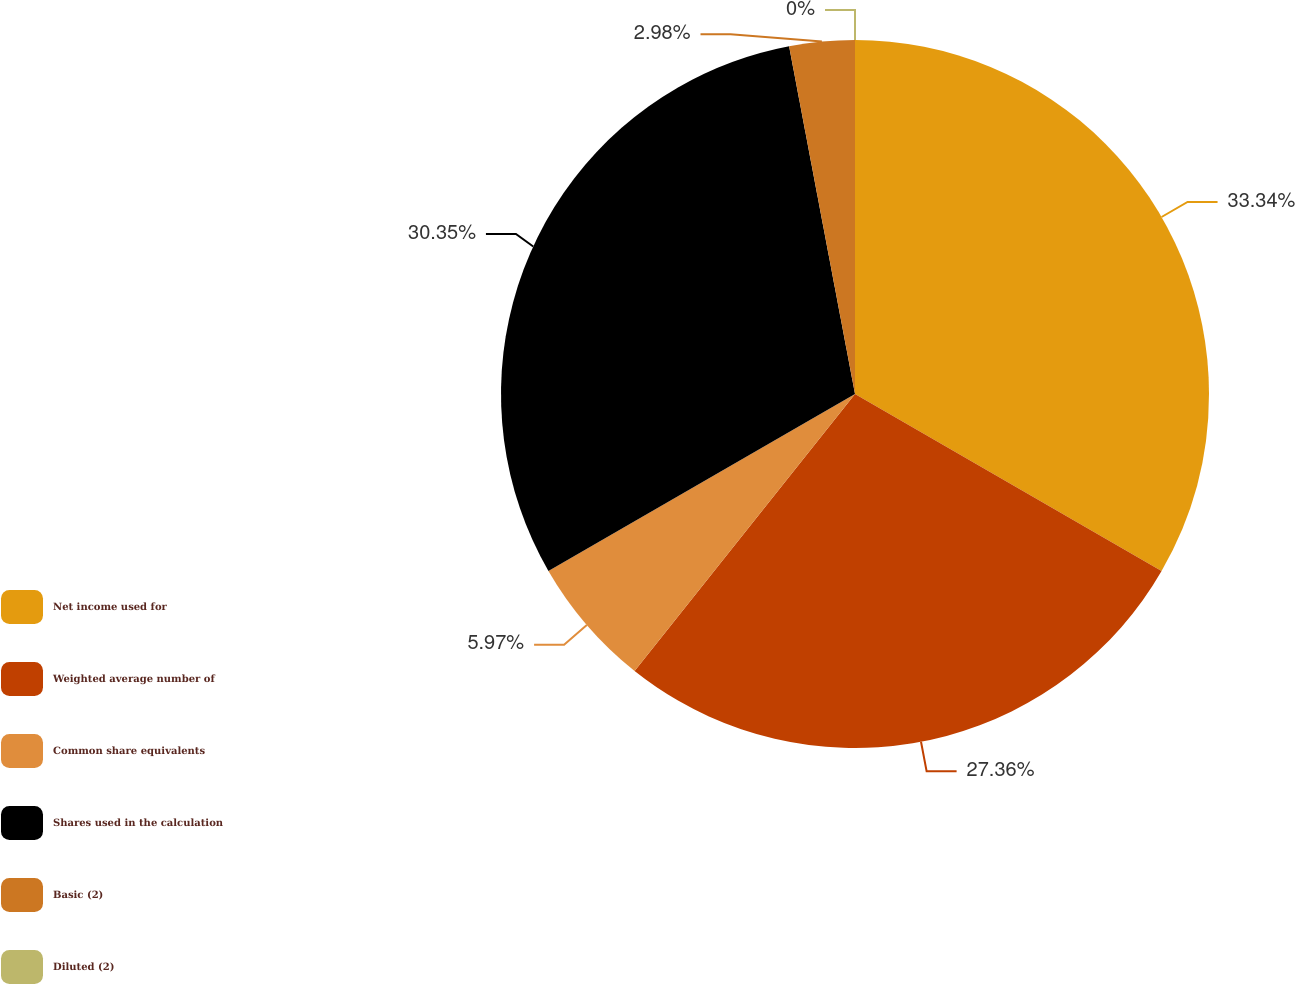Convert chart. <chart><loc_0><loc_0><loc_500><loc_500><pie_chart><fcel>Net income used for<fcel>Weighted average number of<fcel>Common share equivalents<fcel>Shares used in the calculation<fcel>Basic (2)<fcel>Diluted (2)<nl><fcel>33.33%<fcel>27.36%<fcel>5.97%<fcel>30.35%<fcel>2.98%<fcel>0.0%<nl></chart> 